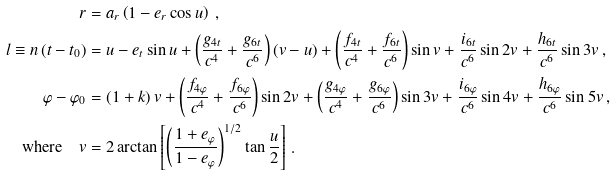<formula> <loc_0><loc_0><loc_500><loc_500>r & = a _ { r } \left ( 1 - e _ { r } \cos u \right ) \, , \\ l \equiv n \left ( t - t _ { 0 } \right ) & = u - e _ { t } \sin u + \left ( \frac { g _ { 4 t } } { c ^ { 4 } } + \frac { g _ { 6 t } } { c ^ { 6 } } \right ) ( v - u ) + \left ( \frac { f _ { 4 t } } { c ^ { 4 } } + \frac { f _ { 6 t } } { c ^ { 6 } } \right ) \sin v + \frac { i _ { 6 t } } { c ^ { 6 } } \sin 2 v + \frac { h _ { 6 t } } { c ^ { 6 } } \sin 3 v \, , \\ \varphi - \varphi _ { 0 } & = ( 1 + k ) \, v + \left ( \frac { f _ { 4 \varphi } } { c ^ { 4 } } + \frac { f _ { 6 \varphi } } { c ^ { 6 } } \right ) \sin 2 v + \left ( \frac { g _ { 4 \varphi } } { c ^ { 4 } } + \frac { g _ { 6 \varphi } } { c ^ { 6 } } \right ) \sin 3 v + \frac { i _ { 6 \varphi } } { c ^ { 6 } } \sin 4 v + \frac { h _ { 6 \varphi } } { c ^ { 6 } } \sin 5 v \, , \\ \text {where} \quad v & = 2 \arctan \left [ \left ( \frac { 1 + e _ { \varphi } } { 1 - e _ { \varphi } } \right ) ^ { 1 / 2 } \tan \frac { u } { 2 } \right ] \, .</formula> 